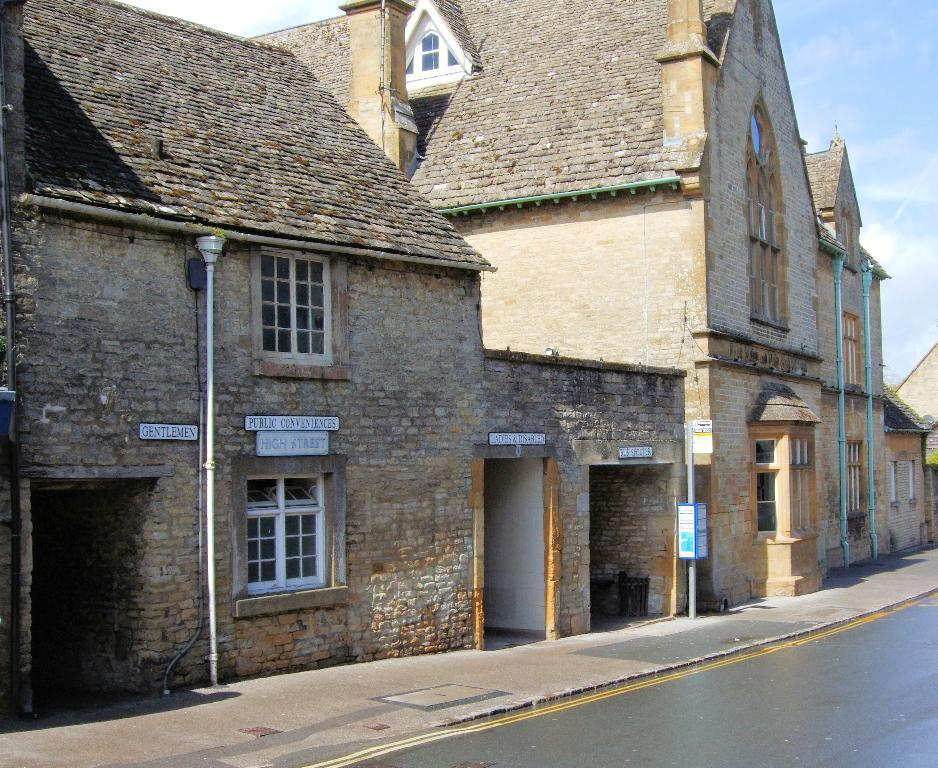What type of structures can be seen in the image? There are buildings in the image. What is written or displayed on the walls of the buildings? There are boards with text on the walls in the image. How would you describe the sky in the image? The sky is blue and cloudy in the image. Can you see any animals flying in the sky in the image? There are no animals visible in the image, and therefore no such activity can be observed. What type of kite is being flown in the image? There is no kite present in the image. 